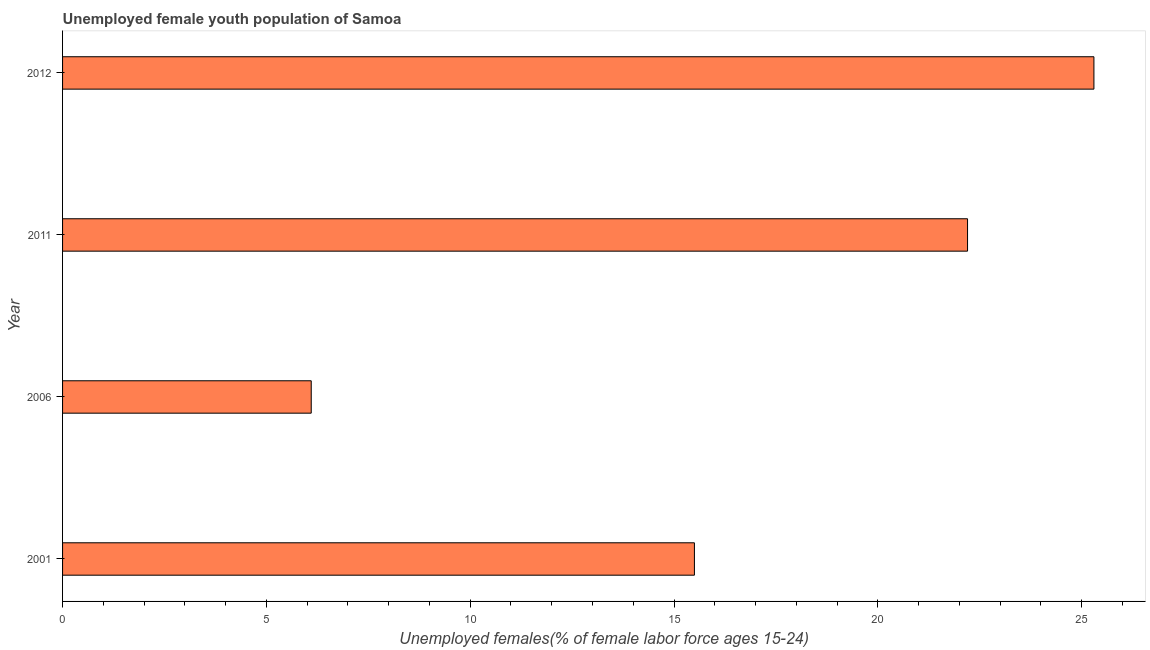Does the graph contain grids?
Provide a succinct answer. No. What is the title of the graph?
Make the answer very short. Unemployed female youth population of Samoa. What is the label or title of the X-axis?
Provide a short and direct response. Unemployed females(% of female labor force ages 15-24). What is the unemployed female youth in 2012?
Your answer should be compact. 25.3. Across all years, what is the maximum unemployed female youth?
Offer a very short reply. 25.3. Across all years, what is the minimum unemployed female youth?
Give a very brief answer. 6.1. In which year was the unemployed female youth maximum?
Provide a succinct answer. 2012. What is the sum of the unemployed female youth?
Make the answer very short. 69.1. What is the average unemployed female youth per year?
Provide a succinct answer. 17.27. What is the median unemployed female youth?
Give a very brief answer. 18.85. In how many years, is the unemployed female youth greater than 2 %?
Give a very brief answer. 4. What is the ratio of the unemployed female youth in 2006 to that in 2011?
Make the answer very short. 0.28. Is the unemployed female youth in 2006 less than that in 2011?
Keep it short and to the point. Yes. Is the difference between the unemployed female youth in 2001 and 2011 greater than the difference between any two years?
Offer a terse response. No. What is the difference between the highest and the second highest unemployed female youth?
Provide a succinct answer. 3.1. What is the difference between the highest and the lowest unemployed female youth?
Offer a terse response. 19.2. How many bars are there?
Your response must be concise. 4. What is the difference between two consecutive major ticks on the X-axis?
Your response must be concise. 5. What is the Unemployed females(% of female labor force ages 15-24) of 2006?
Offer a terse response. 6.1. What is the Unemployed females(% of female labor force ages 15-24) in 2011?
Provide a succinct answer. 22.2. What is the Unemployed females(% of female labor force ages 15-24) of 2012?
Make the answer very short. 25.3. What is the difference between the Unemployed females(% of female labor force ages 15-24) in 2001 and 2012?
Provide a succinct answer. -9.8. What is the difference between the Unemployed females(% of female labor force ages 15-24) in 2006 and 2011?
Offer a terse response. -16.1. What is the difference between the Unemployed females(% of female labor force ages 15-24) in 2006 and 2012?
Keep it short and to the point. -19.2. What is the difference between the Unemployed females(% of female labor force ages 15-24) in 2011 and 2012?
Keep it short and to the point. -3.1. What is the ratio of the Unemployed females(% of female labor force ages 15-24) in 2001 to that in 2006?
Offer a terse response. 2.54. What is the ratio of the Unemployed females(% of female labor force ages 15-24) in 2001 to that in 2011?
Keep it short and to the point. 0.7. What is the ratio of the Unemployed females(% of female labor force ages 15-24) in 2001 to that in 2012?
Provide a succinct answer. 0.61. What is the ratio of the Unemployed females(% of female labor force ages 15-24) in 2006 to that in 2011?
Your answer should be very brief. 0.28. What is the ratio of the Unemployed females(% of female labor force ages 15-24) in 2006 to that in 2012?
Give a very brief answer. 0.24. What is the ratio of the Unemployed females(% of female labor force ages 15-24) in 2011 to that in 2012?
Give a very brief answer. 0.88. 